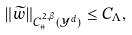<formula> <loc_0><loc_0><loc_500><loc_500>\| \widetilde { w } \| _ { C ^ { 2 , \beta } _ { \# } ( \mathcal { Y } ^ { d } ) } \leq C _ { \Lambda } ,</formula> 